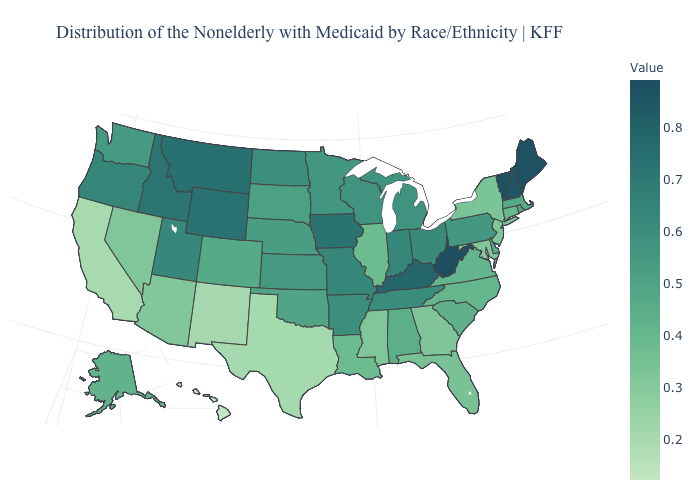Does Colorado have the highest value in the USA?
Be succinct. No. Does Missouri have a lower value than Arizona?
Be succinct. No. 